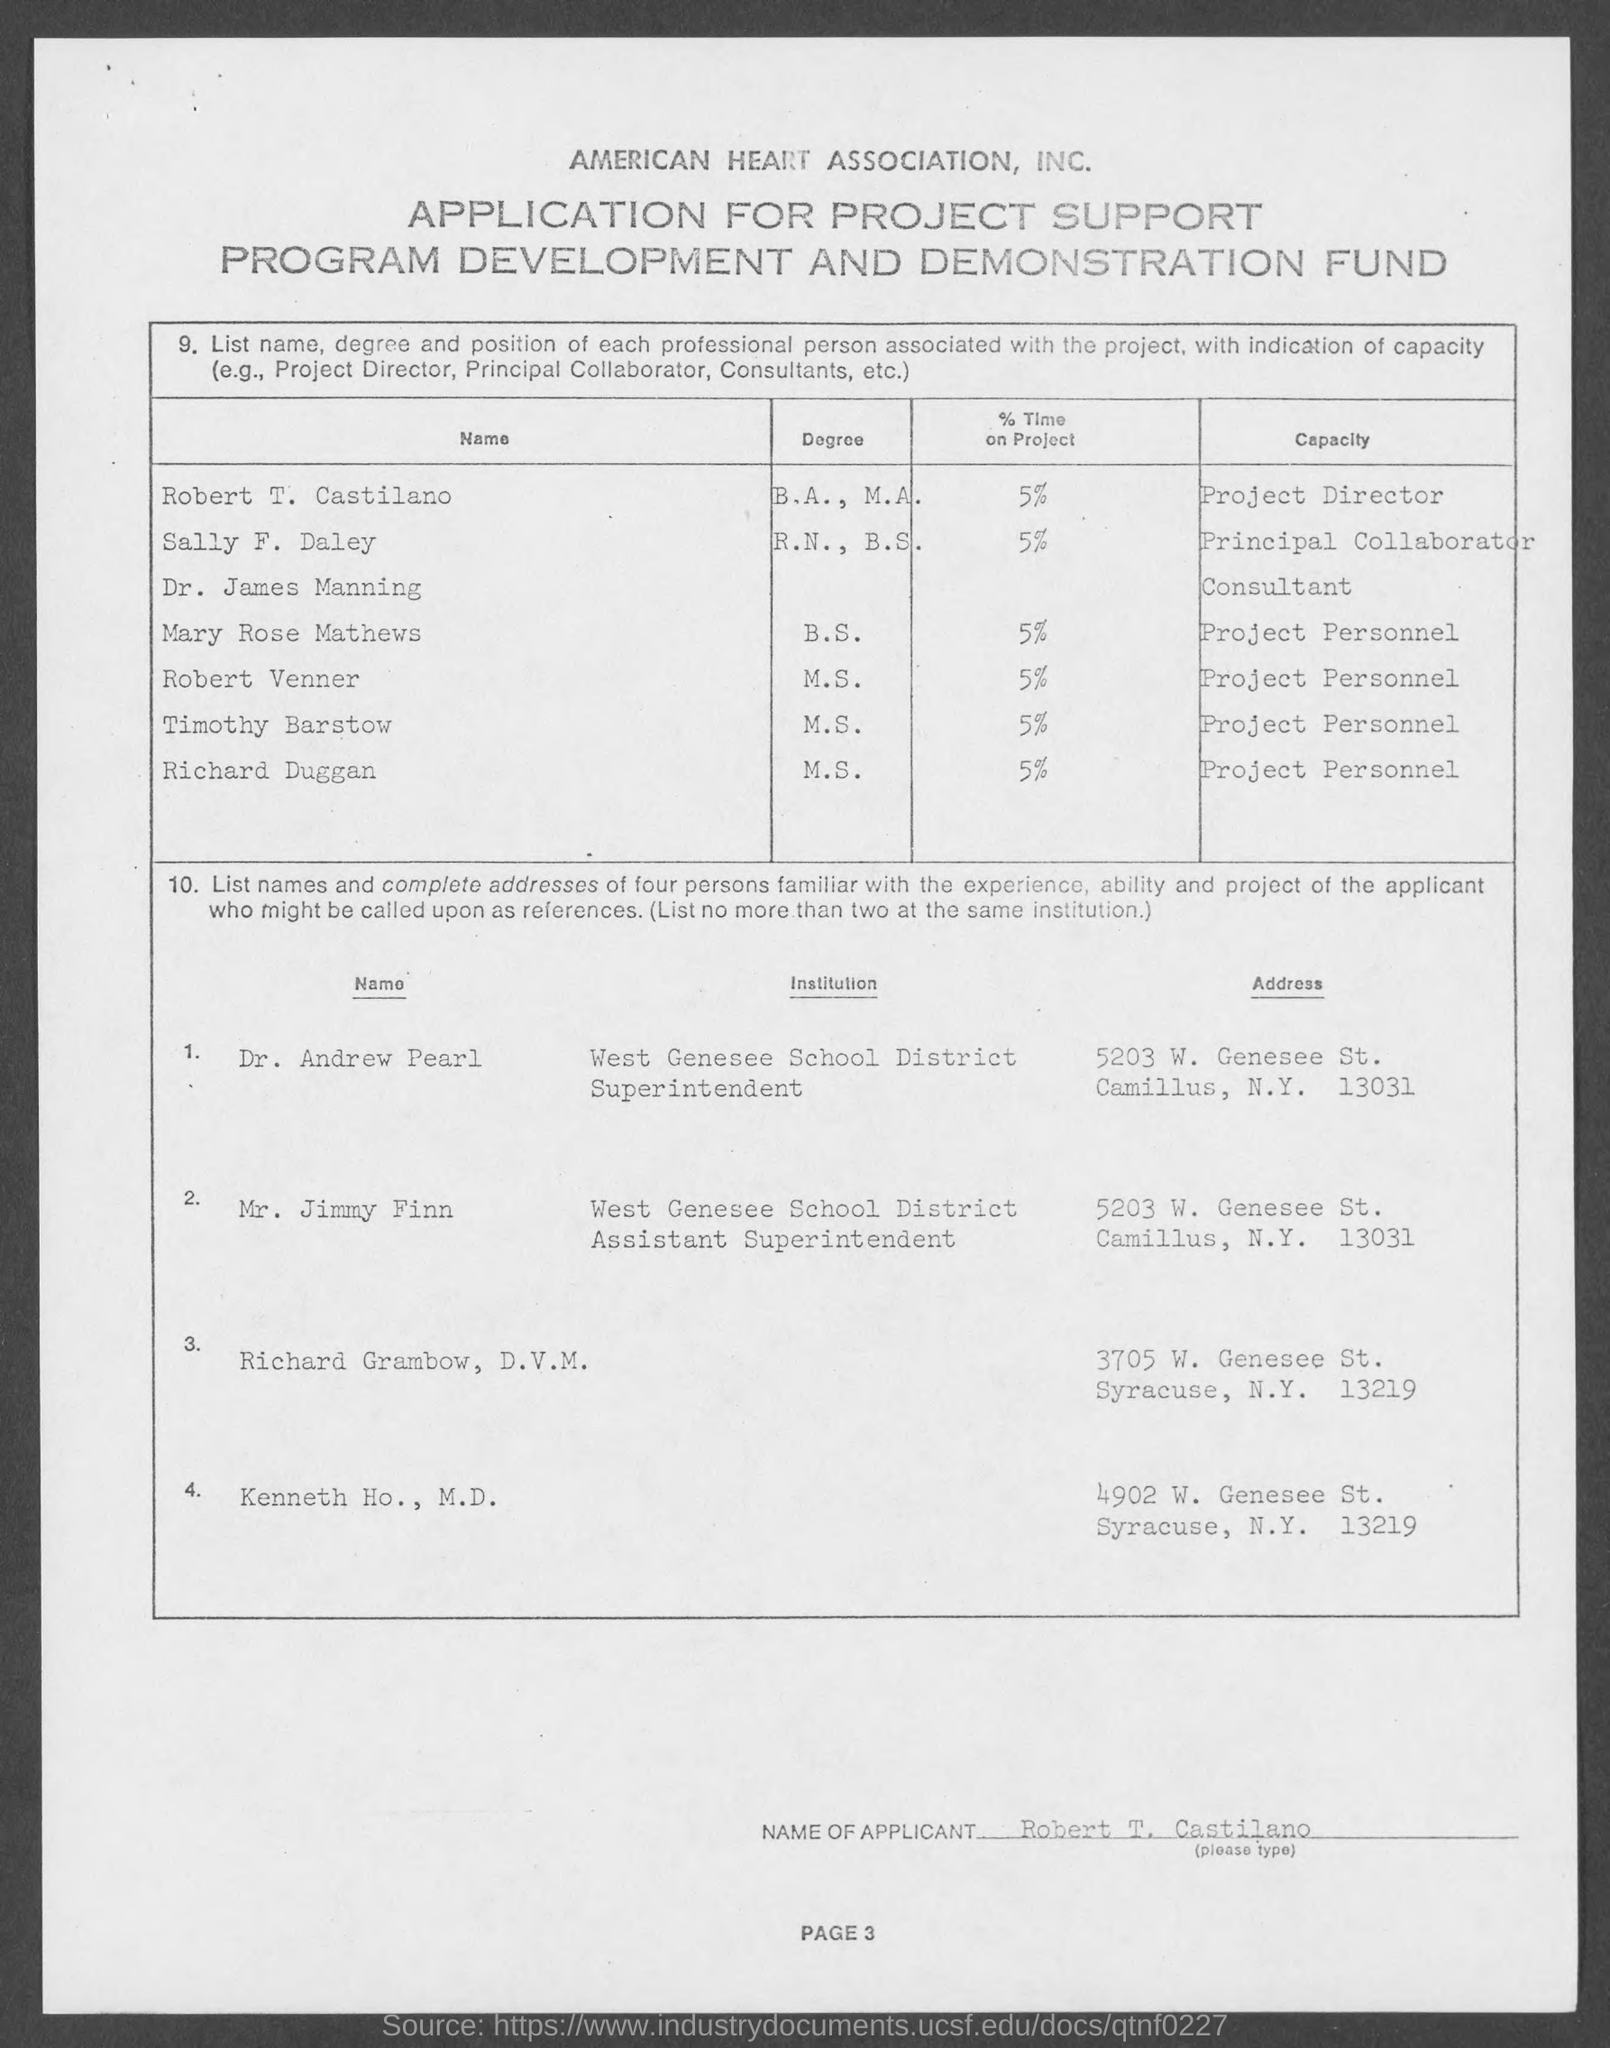What is the capacity of robert venner ?
Your answer should be compact. Project personnel. What is the capacity of sally f. daley ?
Offer a terse response. Principal collaborator. What is the % time on project spent by robert t. castilano ?
Offer a very short reply. 5. What is the capacity of robert t. castilano mentioned in the given page ?
Offer a very short reply. Project director. What is the % time on project spent by mary rose mathews ?
Offer a terse response. 5. What is the capacity of timothy barstow mentioned in the given page ?
Keep it short and to the point. Project personnel. 